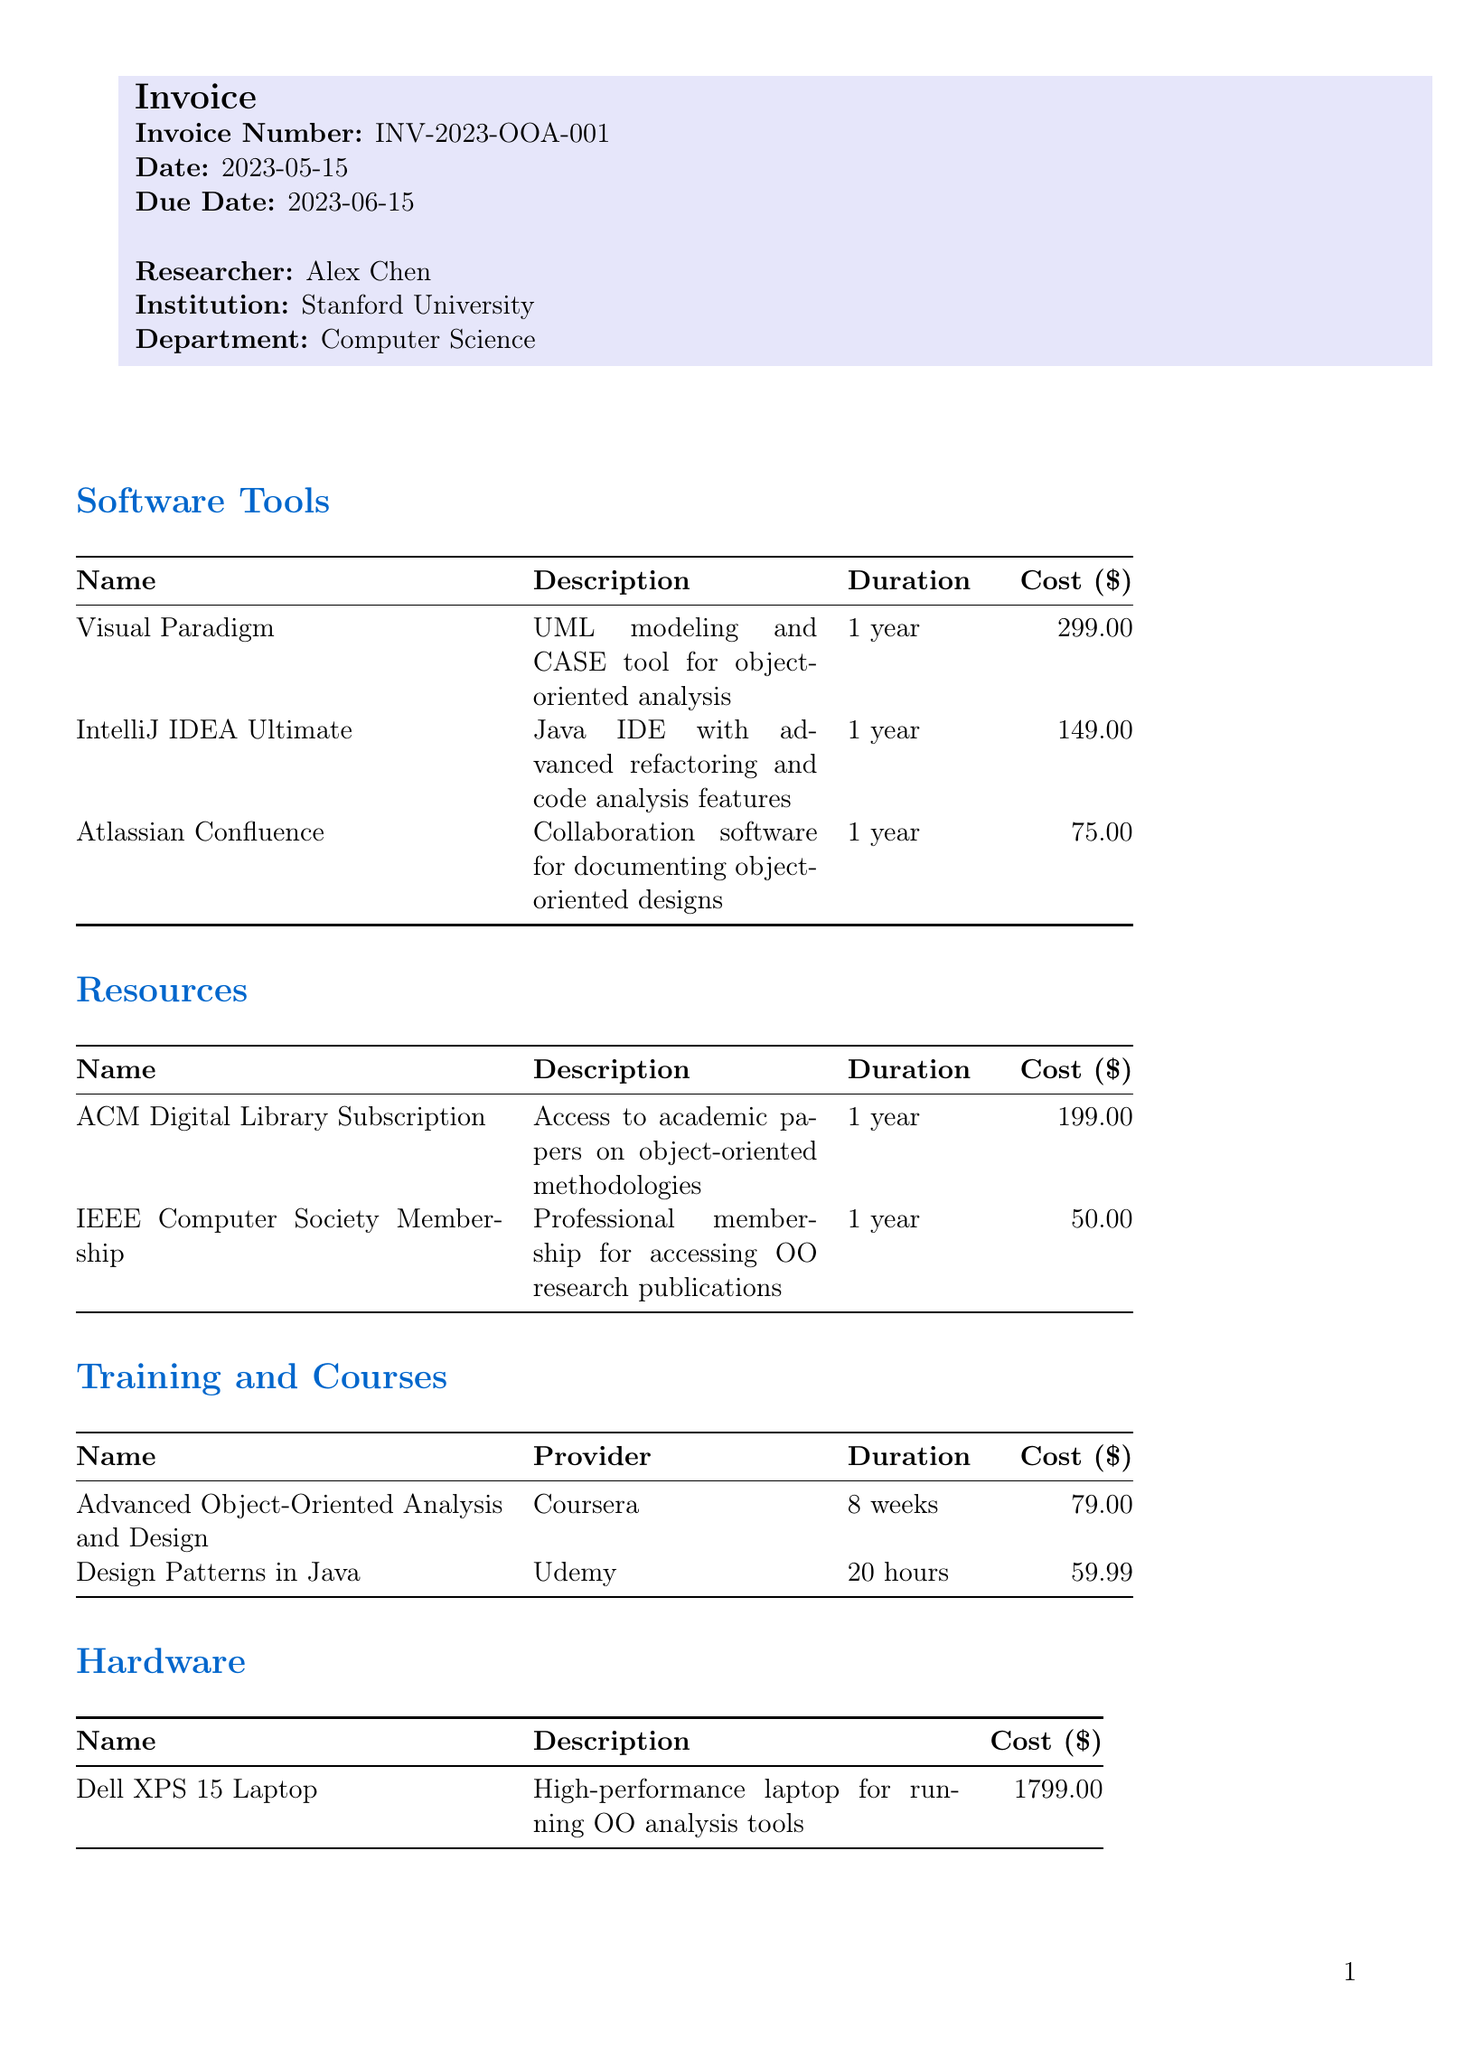what is the invoice number? The invoice number is explicitly stated at the top of the document.
Answer: INV-2023-OOA-001 who is the researcher? The researcher name is mentioned in the invoice details.
Answer: Alex Chen what is the total cost? The total cost is summarized at the end of the invoice.
Answer: 2999.98 what is the license type for Visual Paradigm? The license type is listed alongside the software tools in the invoice.
Answer: Academic how many software tools are listed? The count of the software tools is found in the software tools section of the document.
Answer: 3 what is the duration of the ACM Digital Library Subscription? The duration is described in the resources section.
Answer: 1 year which course is provided by Coursera? The courses section mentions the provider alongside the course name.
Answer: Advanced Object-Oriented Analysis and Design what is the cost of the Dell XPS 15 Laptop? The cost of the hardware item is clearly stated in the hardware section.
Answer: 1799.00 why is cloud computing mentioned in the miscellaneous section? The miscellaneous section details additional expenses that support the main research activities.
Answer: For running distributed OO simulations 